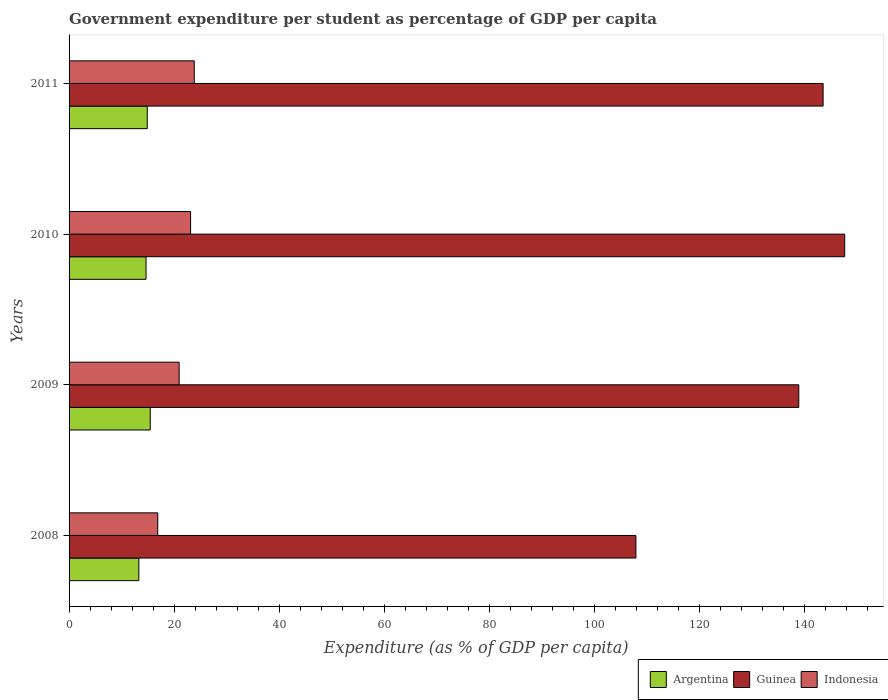Are the number of bars per tick equal to the number of legend labels?
Your answer should be very brief. Yes. Are the number of bars on each tick of the Y-axis equal?
Ensure brevity in your answer.  Yes. How many bars are there on the 4th tick from the top?
Your answer should be compact. 3. What is the percentage of expenditure per student in Argentina in 2010?
Provide a succinct answer. 14.65. Across all years, what is the maximum percentage of expenditure per student in Argentina?
Offer a terse response. 15.46. Across all years, what is the minimum percentage of expenditure per student in Guinea?
Make the answer very short. 107.93. What is the total percentage of expenditure per student in Argentina in the graph?
Give a very brief answer. 58.29. What is the difference between the percentage of expenditure per student in Indonesia in 2009 and that in 2010?
Your answer should be very brief. -2.17. What is the difference between the percentage of expenditure per student in Indonesia in 2010 and the percentage of expenditure per student in Guinea in 2011?
Give a very brief answer. -120.43. What is the average percentage of expenditure per student in Indonesia per year?
Offer a terse response. 21.2. In the year 2009, what is the difference between the percentage of expenditure per student in Argentina and percentage of expenditure per student in Guinea?
Your answer should be compact. -123.48. What is the ratio of the percentage of expenditure per student in Argentina in 2010 to that in 2011?
Offer a terse response. 0.98. What is the difference between the highest and the second highest percentage of expenditure per student in Argentina?
Give a very brief answer. 0.57. What is the difference between the highest and the lowest percentage of expenditure per student in Argentina?
Offer a very short reply. 2.17. In how many years, is the percentage of expenditure per student in Indonesia greater than the average percentage of expenditure per student in Indonesia taken over all years?
Offer a terse response. 2. Is the sum of the percentage of expenditure per student in Indonesia in 2008 and 2009 greater than the maximum percentage of expenditure per student in Argentina across all years?
Provide a succinct answer. Yes. What does the 3rd bar from the top in 2011 represents?
Ensure brevity in your answer.  Argentina. What does the 3rd bar from the bottom in 2011 represents?
Provide a short and direct response. Indonesia. How many years are there in the graph?
Offer a terse response. 4. Does the graph contain grids?
Give a very brief answer. No. Where does the legend appear in the graph?
Keep it short and to the point. Bottom right. How many legend labels are there?
Make the answer very short. 3. What is the title of the graph?
Your answer should be compact. Government expenditure per student as percentage of GDP per capita. Does "Lower middle income" appear as one of the legend labels in the graph?
Give a very brief answer. No. What is the label or title of the X-axis?
Ensure brevity in your answer.  Expenditure (as % of GDP per capita). What is the Expenditure (as % of GDP per capita) in Argentina in 2008?
Offer a terse response. 13.29. What is the Expenditure (as % of GDP per capita) in Guinea in 2008?
Give a very brief answer. 107.93. What is the Expenditure (as % of GDP per capita) in Indonesia in 2008?
Offer a very short reply. 16.89. What is the Expenditure (as % of GDP per capita) in Argentina in 2009?
Offer a very short reply. 15.46. What is the Expenditure (as % of GDP per capita) of Guinea in 2009?
Provide a succinct answer. 138.93. What is the Expenditure (as % of GDP per capita) of Indonesia in 2009?
Offer a very short reply. 20.96. What is the Expenditure (as % of GDP per capita) of Argentina in 2010?
Provide a short and direct response. 14.65. What is the Expenditure (as % of GDP per capita) in Guinea in 2010?
Your answer should be very brief. 147.68. What is the Expenditure (as % of GDP per capita) of Indonesia in 2010?
Give a very brief answer. 23.13. What is the Expenditure (as % of GDP per capita) of Argentina in 2011?
Your response must be concise. 14.89. What is the Expenditure (as % of GDP per capita) in Guinea in 2011?
Your answer should be compact. 143.56. What is the Expenditure (as % of GDP per capita) of Indonesia in 2011?
Provide a succinct answer. 23.84. Across all years, what is the maximum Expenditure (as % of GDP per capita) in Argentina?
Offer a terse response. 15.46. Across all years, what is the maximum Expenditure (as % of GDP per capita) of Guinea?
Give a very brief answer. 147.68. Across all years, what is the maximum Expenditure (as % of GDP per capita) in Indonesia?
Offer a very short reply. 23.84. Across all years, what is the minimum Expenditure (as % of GDP per capita) of Argentina?
Offer a very short reply. 13.29. Across all years, what is the minimum Expenditure (as % of GDP per capita) of Guinea?
Your answer should be very brief. 107.93. Across all years, what is the minimum Expenditure (as % of GDP per capita) of Indonesia?
Provide a short and direct response. 16.89. What is the total Expenditure (as % of GDP per capita) of Argentina in the graph?
Provide a succinct answer. 58.29. What is the total Expenditure (as % of GDP per capita) of Guinea in the graph?
Provide a short and direct response. 538.1. What is the total Expenditure (as % of GDP per capita) of Indonesia in the graph?
Your answer should be very brief. 84.82. What is the difference between the Expenditure (as % of GDP per capita) of Argentina in 2008 and that in 2009?
Ensure brevity in your answer.  -2.17. What is the difference between the Expenditure (as % of GDP per capita) of Guinea in 2008 and that in 2009?
Keep it short and to the point. -31.01. What is the difference between the Expenditure (as % of GDP per capita) of Indonesia in 2008 and that in 2009?
Provide a short and direct response. -4.07. What is the difference between the Expenditure (as % of GDP per capita) of Argentina in 2008 and that in 2010?
Give a very brief answer. -1.37. What is the difference between the Expenditure (as % of GDP per capita) in Guinea in 2008 and that in 2010?
Your response must be concise. -39.75. What is the difference between the Expenditure (as % of GDP per capita) in Indonesia in 2008 and that in 2010?
Offer a very short reply. -6.25. What is the difference between the Expenditure (as % of GDP per capita) of Argentina in 2008 and that in 2011?
Offer a terse response. -1.6. What is the difference between the Expenditure (as % of GDP per capita) in Guinea in 2008 and that in 2011?
Offer a very short reply. -35.64. What is the difference between the Expenditure (as % of GDP per capita) in Indonesia in 2008 and that in 2011?
Provide a short and direct response. -6.95. What is the difference between the Expenditure (as % of GDP per capita) in Argentina in 2009 and that in 2010?
Provide a succinct answer. 0.8. What is the difference between the Expenditure (as % of GDP per capita) in Guinea in 2009 and that in 2010?
Make the answer very short. -8.74. What is the difference between the Expenditure (as % of GDP per capita) of Indonesia in 2009 and that in 2010?
Give a very brief answer. -2.17. What is the difference between the Expenditure (as % of GDP per capita) in Argentina in 2009 and that in 2011?
Provide a short and direct response. 0.57. What is the difference between the Expenditure (as % of GDP per capita) of Guinea in 2009 and that in 2011?
Provide a short and direct response. -4.63. What is the difference between the Expenditure (as % of GDP per capita) in Indonesia in 2009 and that in 2011?
Offer a very short reply. -2.88. What is the difference between the Expenditure (as % of GDP per capita) in Argentina in 2010 and that in 2011?
Your answer should be very brief. -0.24. What is the difference between the Expenditure (as % of GDP per capita) in Guinea in 2010 and that in 2011?
Give a very brief answer. 4.11. What is the difference between the Expenditure (as % of GDP per capita) in Indonesia in 2010 and that in 2011?
Make the answer very short. -0.7. What is the difference between the Expenditure (as % of GDP per capita) of Argentina in 2008 and the Expenditure (as % of GDP per capita) of Guinea in 2009?
Offer a terse response. -125.65. What is the difference between the Expenditure (as % of GDP per capita) in Argentina in 2008 and the Expenditure (as % of GDP per capita) in Indonesia in 2009?
Make the answer very short. -7.67. What is the difference between the Expenditure (as % of GDP per capita) in Guinea in 2008 and the Expenditure (as % of GDP per capita) in Indonesia in 2009?
Provide a short and direct response. 86.97. What is the difference between the Expenditure (as % of GDP per capita) in Argentina in 2008 and the Expenditure (as % of GDP per capita) in Guinea in 2010?
Your answer should be compact. -134.39. What is the difference between the Expenditure (as % of GDP per capita) of Argentina in 2008 and the Expenditure (as % of GDP per capita) of Indonesia in 2010?
Your response must be concise. -9.85. What is the difference between the Expenditure (as % of GDP per capita) in Guinea in 2008 and the Expenditure (as % of GDP per capita) in Indonesia in 2010?
Provide a succinct answer. 84.79. What is the difference between the Expenditure (as % of GDP per capita) in Argentina in 2008 and the Expenditure (as % of GDP per capita) in Guinea in 2011?
Offer a very short reply. -130.28. What is the difference between the Expenditure (as % of GDP per capita) of Argentina in 2008 and the Expenditure (as % of GDP per capita) of Indonesia in 2011?
Your answer should be compact. -10.55. What is the difference between the Expenditure (as % of GDP per capita) of Guinea in 2008 and the Expenditure (as % of GDP per capita) of Indonesia in 2011?
Offer a terse response. 84.09. What is the difference between the Expenditure (as % of GDP per capita) in Argentina in 2009 and the Expenditure (as % of GDP per capita) in Guinea in 2010?
Provide a short and direct response. -132.22. What is the difference between the Expenditure (as % of GDP per capita) of Argentina in 2009 and the Expenditure (as % of GDP per capita) of Indonesia in 2010?
Your answer should be compact. -7.68. What is the difference between the Expenditure (as % of GDP per capita) in Guinea in 2009 and the Expenditure (as % of GDP per capita) in Indonesia in 2010?
Keep it short and to the point. 115.8. What is the difference between the Expenditure (as % of GDP per capita) in Argentina in 2009 and the Expenditure (as % of GDP per capita) in Guinea in 2011?
Ensure brevity in your answer.  -128.11. What is the difference between the Expenditure (as % of GDP per capita) in Argentina in 2009 and the Expenditure (as % of GDP per capita) in Indonesia in 2011?
Give a very brief answer. -8.38. What is the difference between the Expenditure (as % of GDP per capita) of Guinea in 2009 and the Expenditure (as % of GDP per capita) of Indonesia in 2011?
Your response must be concise. 115.09. What is the difference between the Expenditure (as % of GDP per capita) in Argentina in 2010 and the Expenditure (as % of GDP per capita) in Guinea in 2011?
Offer a very short reply. -128.91. What is the difference between the Expenditure (as % of GDP per capita) of Argentina in 2010 and the Expenditure (as % of GDP per capita) of Indonesia in 2011?
Offer a terse response. -9.18. What is the difference between the Expenditure (as % of GDP per capita) in Guinea in 2010 and the Expenditure (as % of GDP per capita) in Indonesia in 2011?
Keep it short and to the point. 123.84. What is the average Expenditure (as % of GDP per capita) of Argentina per year?
Your answer should be compact. 14.57. What is the average Expenditure (as % of GDP per capita) of Guinea per year?
Your response must be concise. 134.52. What is the average Expenditure (as % of GDP per capita) of Indonesia per year?
Your answer should be compact. 21.2. In the year 2008, what is the difference between the Expenditure (as % of GDP per capita) of Argentina and Expenditure (as % of GDP per capita) of Guinea?
Your response must be concise. -94.64. In the year 2008, what is the difference between the Expenditure (as % of GDP per capita) in Argentina and Expenditure (as % of GDP per capita) in Indonesia?
Your response must be concise. -3.6. In the year 2008, what is the difference between the Expenditure (as % of GDP per capita) in Guinea and Expenditure (as % of GDP per capita) in Indonesia?
Your answer should be very brief. 91.04. In the year 2009, what is the difference between the Expenditure (as % of GDP per capita) in Argentina and Expenditure (as % of GDP per capita) in Guinea?
Ensure brevity in your answer.  -123.48. In the year 2009, what is the difference between the Expenditure (as % of GDP per capita) in Argentina and Expenditure (as % of GDP per capita) in Indonesia?
Make the answer very short. -5.5. In the year 2009, what is the difference between the Expenditure (as % of GDP per capita) in Guinea and Expenditure (as % of GDP per capita) in Indonesia?
Provide a short and direct response. 117.97. In the year 2010, what is the difference between the Expenditure (as % of GDP per capita) in Argentina and Expenditure (as % of GDP per capita) in Guinea?
Your response must be concise. -133.02. In the year 2010, what is the difference between the Expenditure (as % of GDP per capita) of Argentina and Expenditure (as % of GDP per capita) of Indonesia?
Offer a terse response. -8.48. In the year 2010, what is the difference between the Expenditure (as % of GDP per capita) in Guinea and Expenditure (as % of GDP per capita) in Indonesia?
Your answer should be very brief. 124.54. In the year 2011, what is the difference between the Expenditure (as % of GDP per capita) in Argentina and Expenditure (as % of GDP per capita) in Guinea?
Provide a succinct answer. -128.67. In the year 2011, what is the difference between the Expenditure (as % of GDP per capita) of Argentina and Expenditure (as % of GDP per capita) of Indonesia?
Give a very brief answer. -8.95. In the year 2011, what is the difference between the Expenditure (as % of GDP per capita) of Guinea and Expenditure (as % of GDP per capita) of Indonesia?
Your answer should be very brief. 119.73. What is the ratio of the Expenditure (as % of GDP per capita) in Argentina in 2008 to that in 2009?
Offer a terse response. 0.86. What is the ratio of the Expenditure (as % of GDP per capita) of Guinea in 2008 to that in 2009?
Your response must be concise. 0.78. What is the ratio of the Expenditure (as % of GDP per capita) of Indonesia in 2008 to that in 2009?
Make the answer very short. 0.81. What is the ratio of the Expenditure (as % of GDP per capita) of Argentina in 2008 to that in 2010?
Offer a terse response. 0.91. What is the ratio of the Expenditure (as % of GDP per capita) of Guinea in 2008 to that in 2010?
Provide a succinct answer. 0.73. What is the ratio of the Expenditure (as % of GDP per capita) in Indonesia in 2008 to that in 2010?
Provide a short and direct response. 0.73. What is the ratio of the Expenditure (as % of GDP per capita) in Argentina in 2008 to that in 2011?
Give a very brief answer. 0.89. What is the ratio of the Expenditure (as % of GDP per capita) of Guinea in 2008 to that in 2011?
Keep it short and to the point. 0.75. What is the ratio of the Expenditure (as % of GDP per capita) of Indonesia in 2008 to that in 2011?
Your response must be concise. 0.71. What is the ratio of the Expenditure (as % of GDP per capita) of Argentina in 2009 to that in 2010?
Provide a short and direct response. 1.05. What is the ratio of the Expenditure (as % of GDP per capita) in Guinea in 2009 to that in 2010?
Your answer should be compact. 0.94. What is the ratio of the Expenditure (as % of GDP per capita) of Indonesia in 2009 to that in 2010?
Provide a short and direct response. 0.91. What is the ratio of the Expenditure (as % of GDP per capita) of Argentina in 2009 to that in 2011?
Keep it short and to the point. 1.04. What is the ratio of the Expenditure (as % of GDP per capita) of Indonesia in 2009 to that in 2011?
Your answer should be very brief. 0.88. What is the ratio of the Expenditure (as % of GDP per capita) of Argentina in 2010 to that in 2011?
Your answer should be very brief. 0.98. What is the ratio of the Expenditure (as % of GDP per capita) in Guinea in 2010 to that in 2011?
Keep it short and to the point. 1.03. What is the ratio of the Expenditure (as % of GDP per capita) in Indonesia in 2010 to that in 2011?
Offer a very short reply. 0.97. What is the difference between the highest and the second highest Expenditure (as % of GDP per capita) of Argentina?
Your answer should be very brief. 0.57. What is the difference between the highest and the second highest Expenditure (as % of GDP per capita) of Guinea?
Your answer should be very brief. 4.11. What is the difference between the highest and the second highest Expenditure (as % of GDP per capita) in Indonesia?
Provide a succinct answer. 0.7. What is the difference between the highest and the lowest Expenditure (as % of GDP per capita) of Argentina?
Keep it short and to the point. 2.17. What is the difference between the highest and the lowest Expenditure (as % of GDP per capita) in Guinea?
Your answer should be compact. 39.75. What is the difference between the highest and the lowest Expenditure (as % of GDP per capita) in Indonesia?
Ensure brevity in your answer.  6.95. 